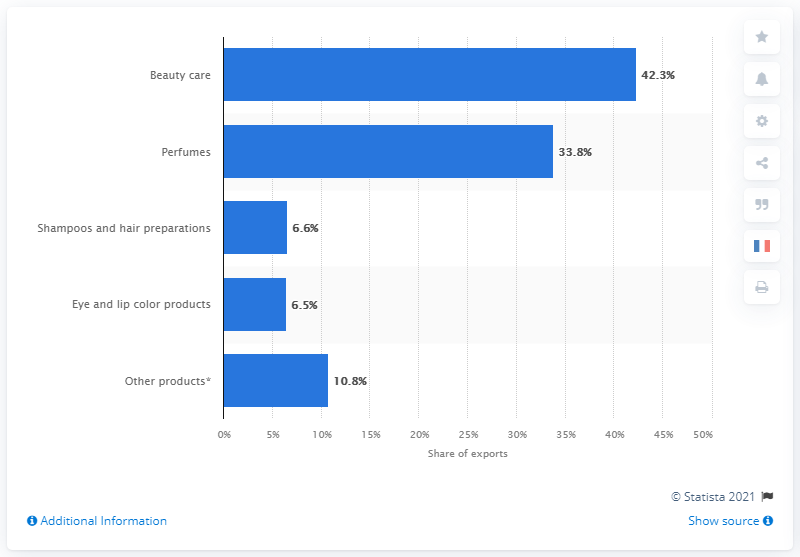Mention a couple of crucial points in this snapshot. In 2020, a significant proportion of French cosmetic exports were beauty care products, representing 42.3% of the total. According to data, 33.8% of French cosmetic exports are composed of perfumes. 